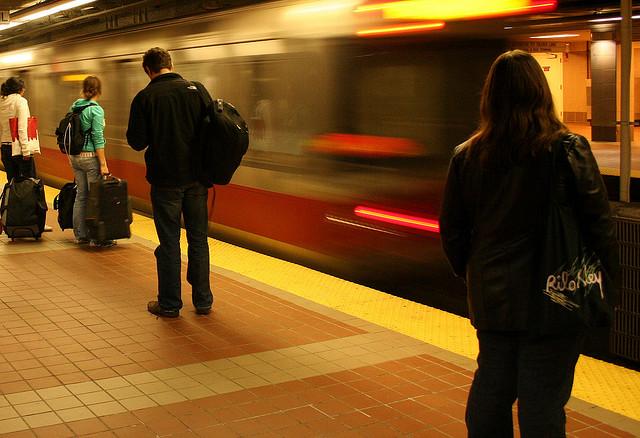What material is the floor made of?
Be succinct. Tile. Is the train moving?
Concise answer only. Yes. How many of the passengers waiting for the train have at least one bag with them?
Answer briefly. 4. 